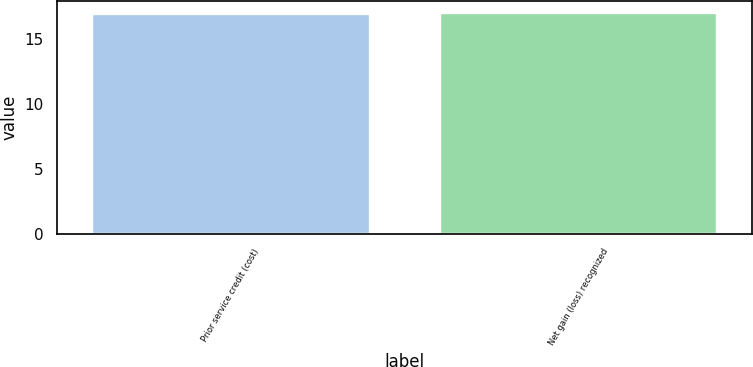<chart> <loc_0><loc_0><loc_500><loc_500><bar_chart><fcel>Prior service credit (cost)<fcel>Net gain (loss) recognized<nl><fcel>17<fcel>17.1<nl></chart> 